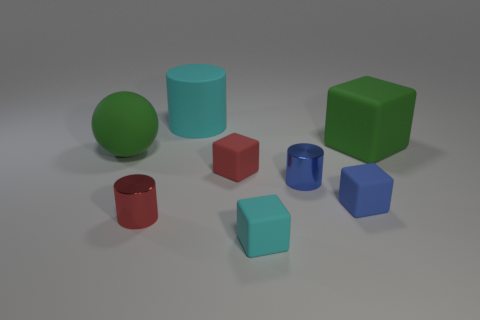What is the material of the tiny red object in front of the blue object that is on the left side of the blue block?
Provide a succinct answer. Metal. What shape is the blue rubber object?
Offer a very short reply. Cube. There is another large object that is the same shape as the blue matte object; what is it made of?
Make the answer very short. Rubber. What number of red metal cylinders have the same size as the cyan rubber cylinder?
Your answer should be compact. 0. Are there any green objects on the left side of the cylinder that is on the left side of the large cyan cylinder?
Keep it short and to the point. Yes. How many red things are either cubes or spheres?
Your response must be concise. 1. The large sphere has what color?
Provide a succinct answer. Green. What is the size of the other cylinder that is made of the same material as the blue cylinder?
Offer a terse response. Small. How many blue shiny objects have the same shape as the small red shiny thing?
Provide a succinct answer. 1. There is a cyan matte object behind the large green thing to the right of the large sphere; how big is it?
Your answer should be compact. Large. 